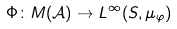Convert formula to latex. <formula><loc_0><loc_0><loc_500><loc_500>\Phi \colon M ( { \mathcal { A } } ) \to L ^ { \infty } ( S , \mu _ { \varphi } )</formula> 